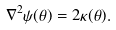<formula> <loc_0><loc_0><loc_500><loc_500>\nabla ^ { 2 } \psi ( { \mathbf \theta } ) = 2 \kappa ( { \mathbf \theta } ) .</formula> 